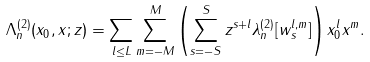<formula> <loc_0><loc_0><loc_500><loc_500>\Lambda ^ { ( 2 ) } _ { n } ( x _ { 0 } , x ; z ) = \sum _ { l \leq L } \sum _ { m = - M } ^ { M } \left ( \sum _ { s = - S } ^ { S } z ^ { s + l } \lambda ^ { ( 2 ) } _ { n } [ w ^ { l , m } _ { s } ] \right ) x _ { 0 } ^ { l } x ^ { m } .</formula> 